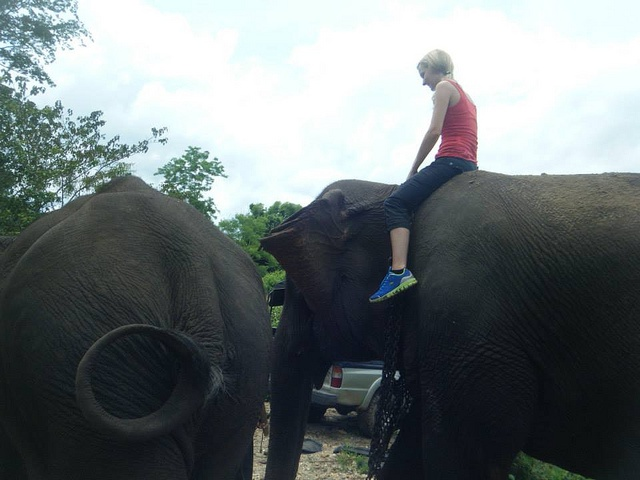Describe the objects in this image and their specific colors. I can see elephant in teal, black, gray, and purple tones, elephant in teal, black, gray, and purple tones, people in teal, black, darkgray, brown, and navy tones, and truck in teal, black, gray, navy, and purple tones in this image. 